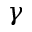<formula> <loc_0><loc_0><loc_500><loc_500>\gamma</formula> 